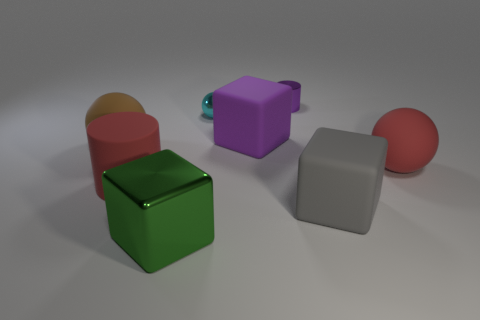Add 1 matte spheres. How many objects exist? 9 Subtract all cylinders. How many objects are left? 6 Add 3 small metal objects. How many small metal objects exist? 5 Subtract 0 brown cylinders. How many objects are left? 8 Subtract all brown objects. Subtract all brown things. How many objects are left? 6 Add 7 big brown objects. How many big brown objects are left? 8 